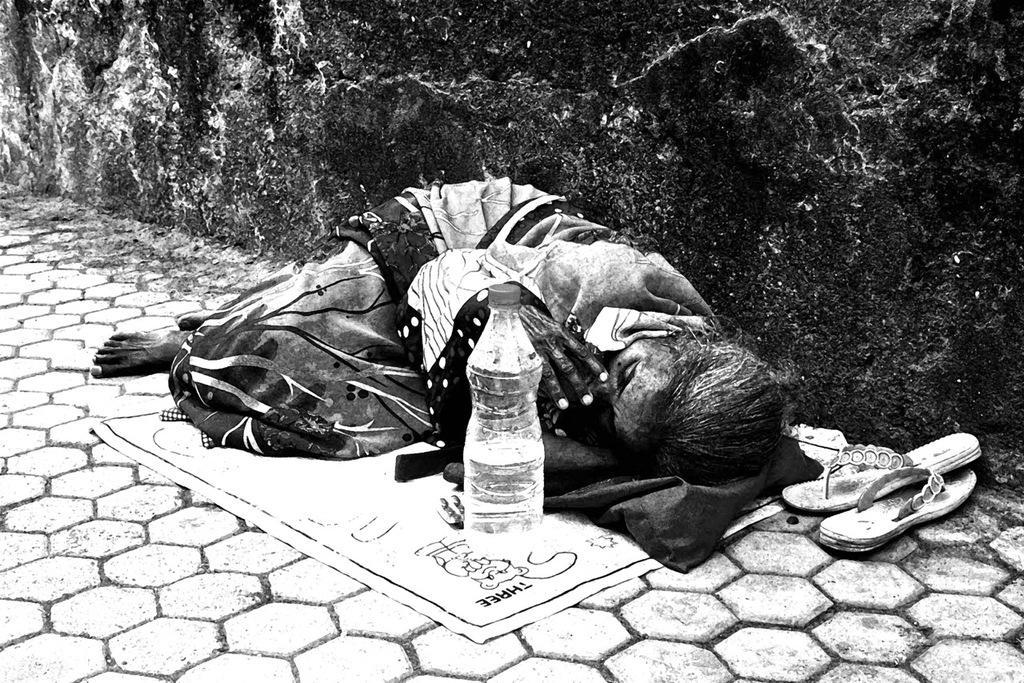In one or two sentences, can you explain what this image depicts? In the center we can see one woman one woman lying on the floor. In front there is a water bottle and paper,on the right we can see slipper. In the background there is a wall. 